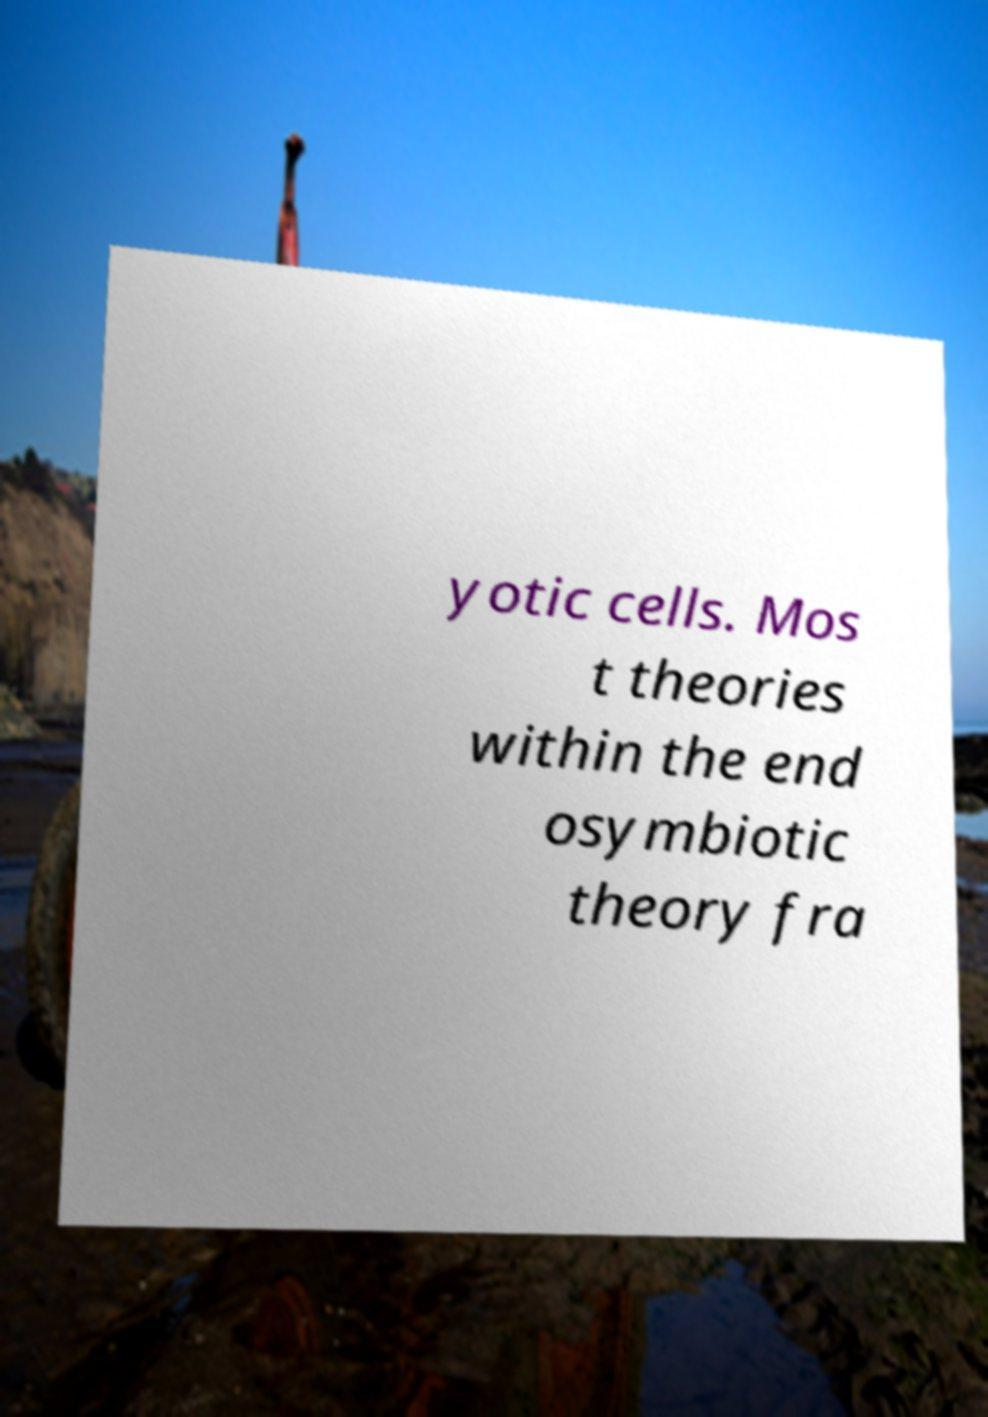There's text embedded in this image that I need extracted. Can you transcribe it verbatim? yotic cells. Mos t theories within the end osymbiotic theory fra 